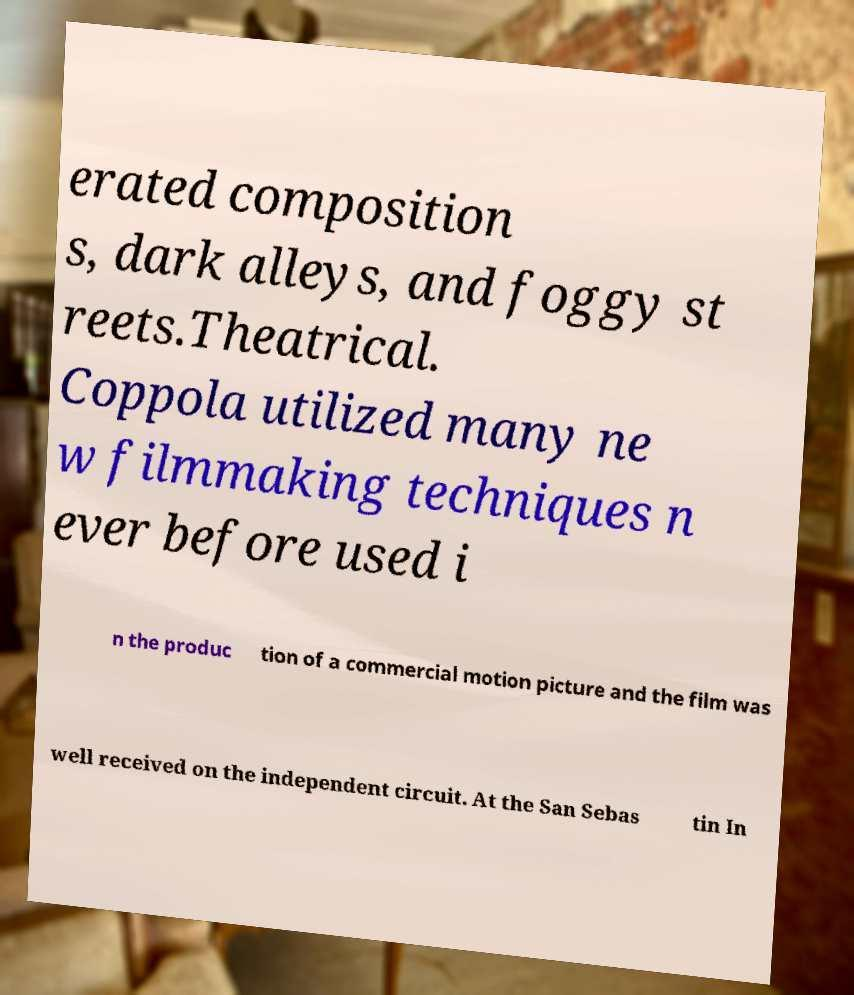Please read and relay the text visible in this image. What does it say? erated composition s, dark alleys, and foggy st reets.Theatrical. Coppola utilized many ne w filmmaking techniques n ever before used i n the produc tion of a commercial motion picture and the film was well received on the independent circuit. At the San Sebas tin In 